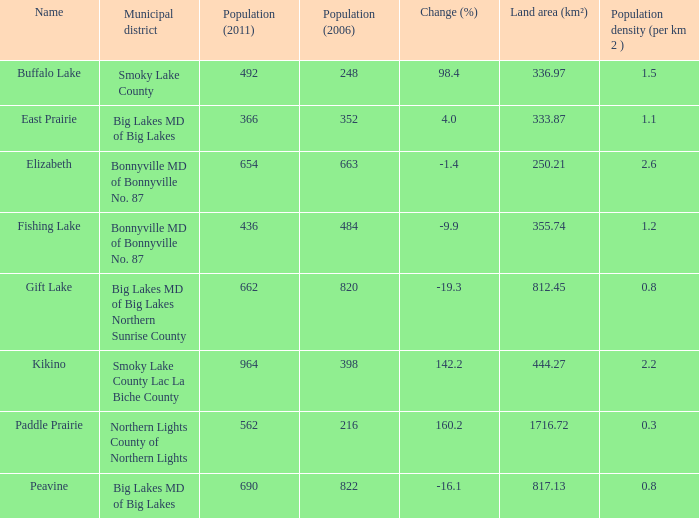What is the density per km in Smoky Lake County? 1.5. 